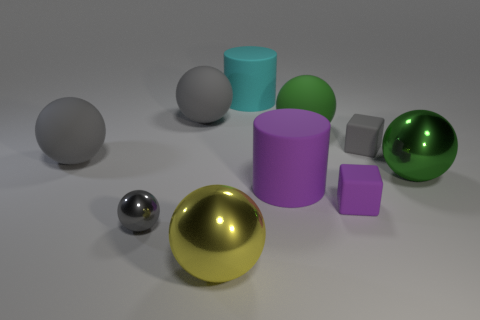What number of other objects are the same shape as the big green metallic thing?
Keep it short and to the point. 5. Are there more gray spheres right of the purple cube than matte cubes that are to the right of the green metal sphere?
Provide a succinct answer. No. Does the metal object to the right of the gray rubber block have the same size as the rubber cube in front of the large green shiny ball?
Offer a terse response. No. What shape is the tiny gray rubber object?
Provide a succinct answer. Cube. The cube that is the same color as the small sphere is what size?
Offer a terse response. Small. There is a cylinder that is the same material as the big purple thing; what color is it?
Your answer should be very brief. Cyan. Does the large cyan thing have the same material as the big gray sphere that is on the left side of the gray metallic ball?
Offer a terse response. Yes. What color is the small metallic object?
Give a very brief answer. Gray. What size is the green thing that is the same material as the big cyan thing?
Keep it short and to the point. Large. How many big metallic balls are behind the large gray rubber object that is on the left side of the gray object in front of the purple rubber cube?
Offer a very short reply. 0. 